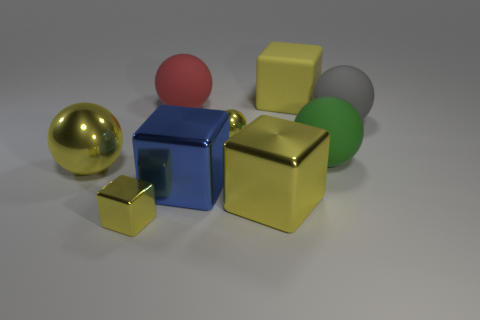What color is the rubber block that is the same size as the red object? The rubber block that is the same size as the red sphere is yellow, displaying a vibrant and glossy finish. 